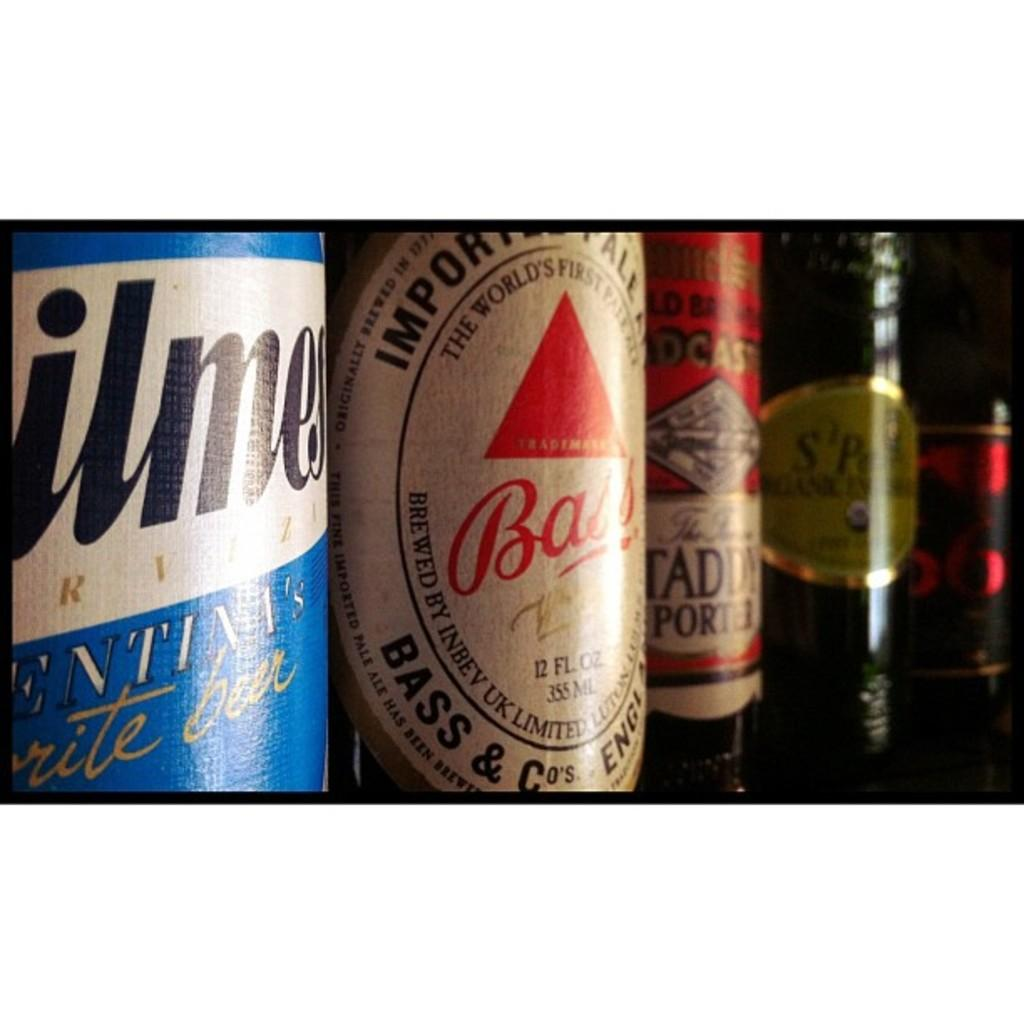<image>
Offer a succinct explanation of the picture presented. A line of beer bottles including a bottle of Bass, world's first Pale Ale brewed in the UK. 